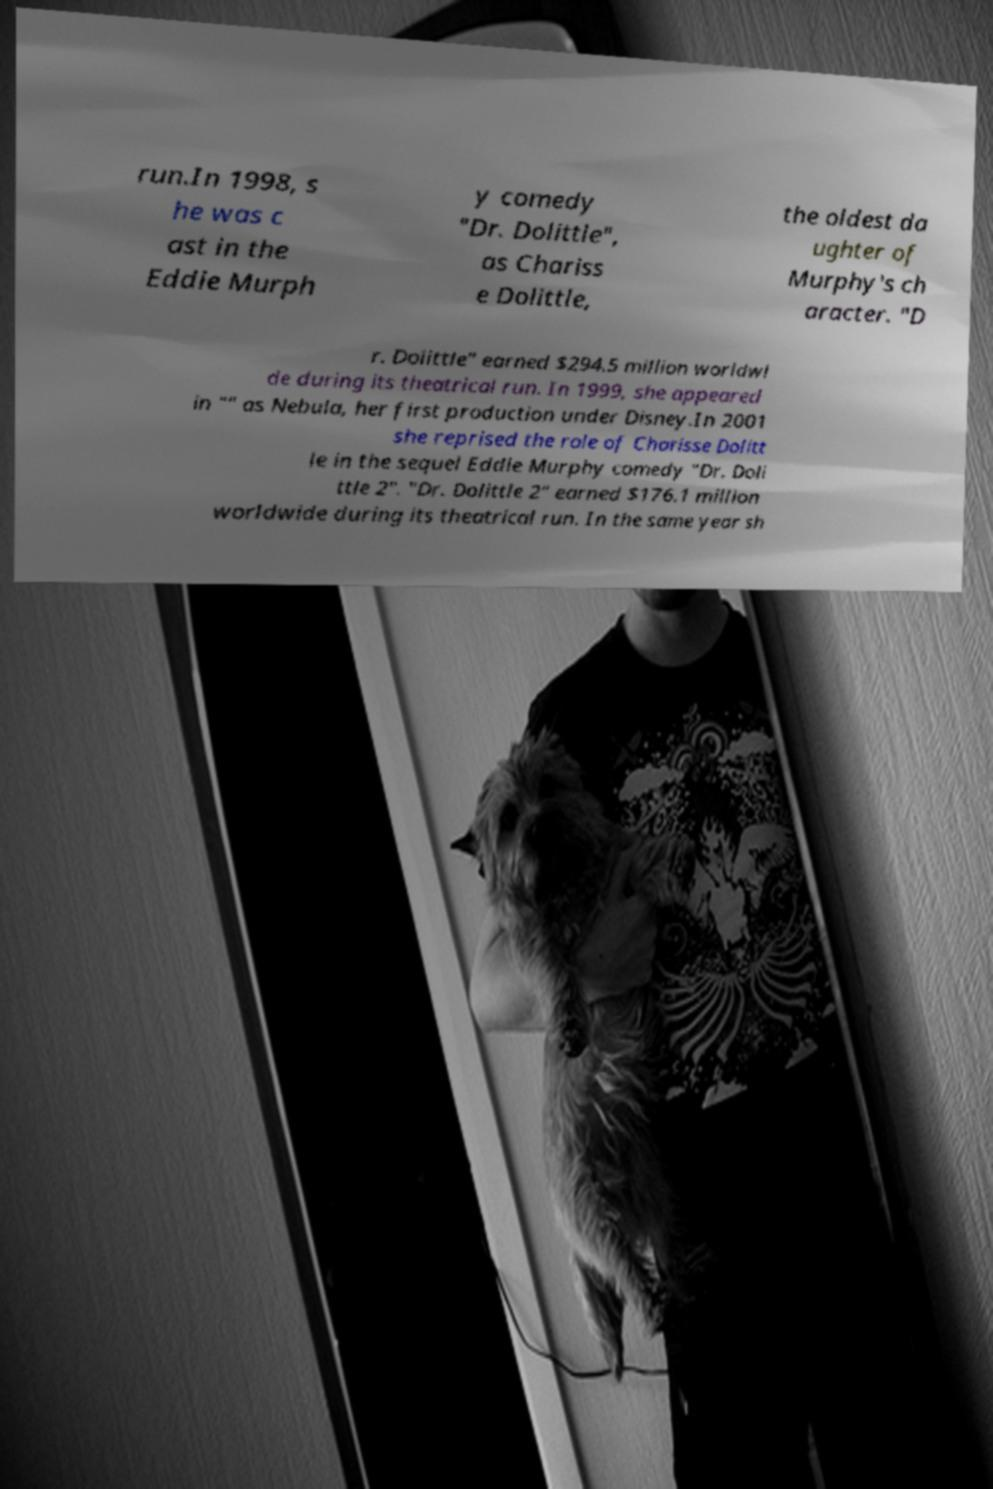Can you read and provide the text displayed in the image?This photo seems to have some interesting text. Can you extract and type it out for me? run.In 1998, s he was c ast in the Eddie Murph y comedy "Dr. Dolittle", as Chariss e Dolittle, the oldest da ughter of Murphy's ch aracter. "D r. Dolittle" earned $294.5 million worldwi de during its theatrical run. In 1999, she appeared in "" as Nebula, her first production under Disney.In 2001 she reprised the role of Charisse Dolitt le in the sequel Eddie Murphy comedy "Dr. Doli ttle 2". "Dr. Dolittle 2" earned $176.1 million worldwide during its theatrical run. In the same year sh 